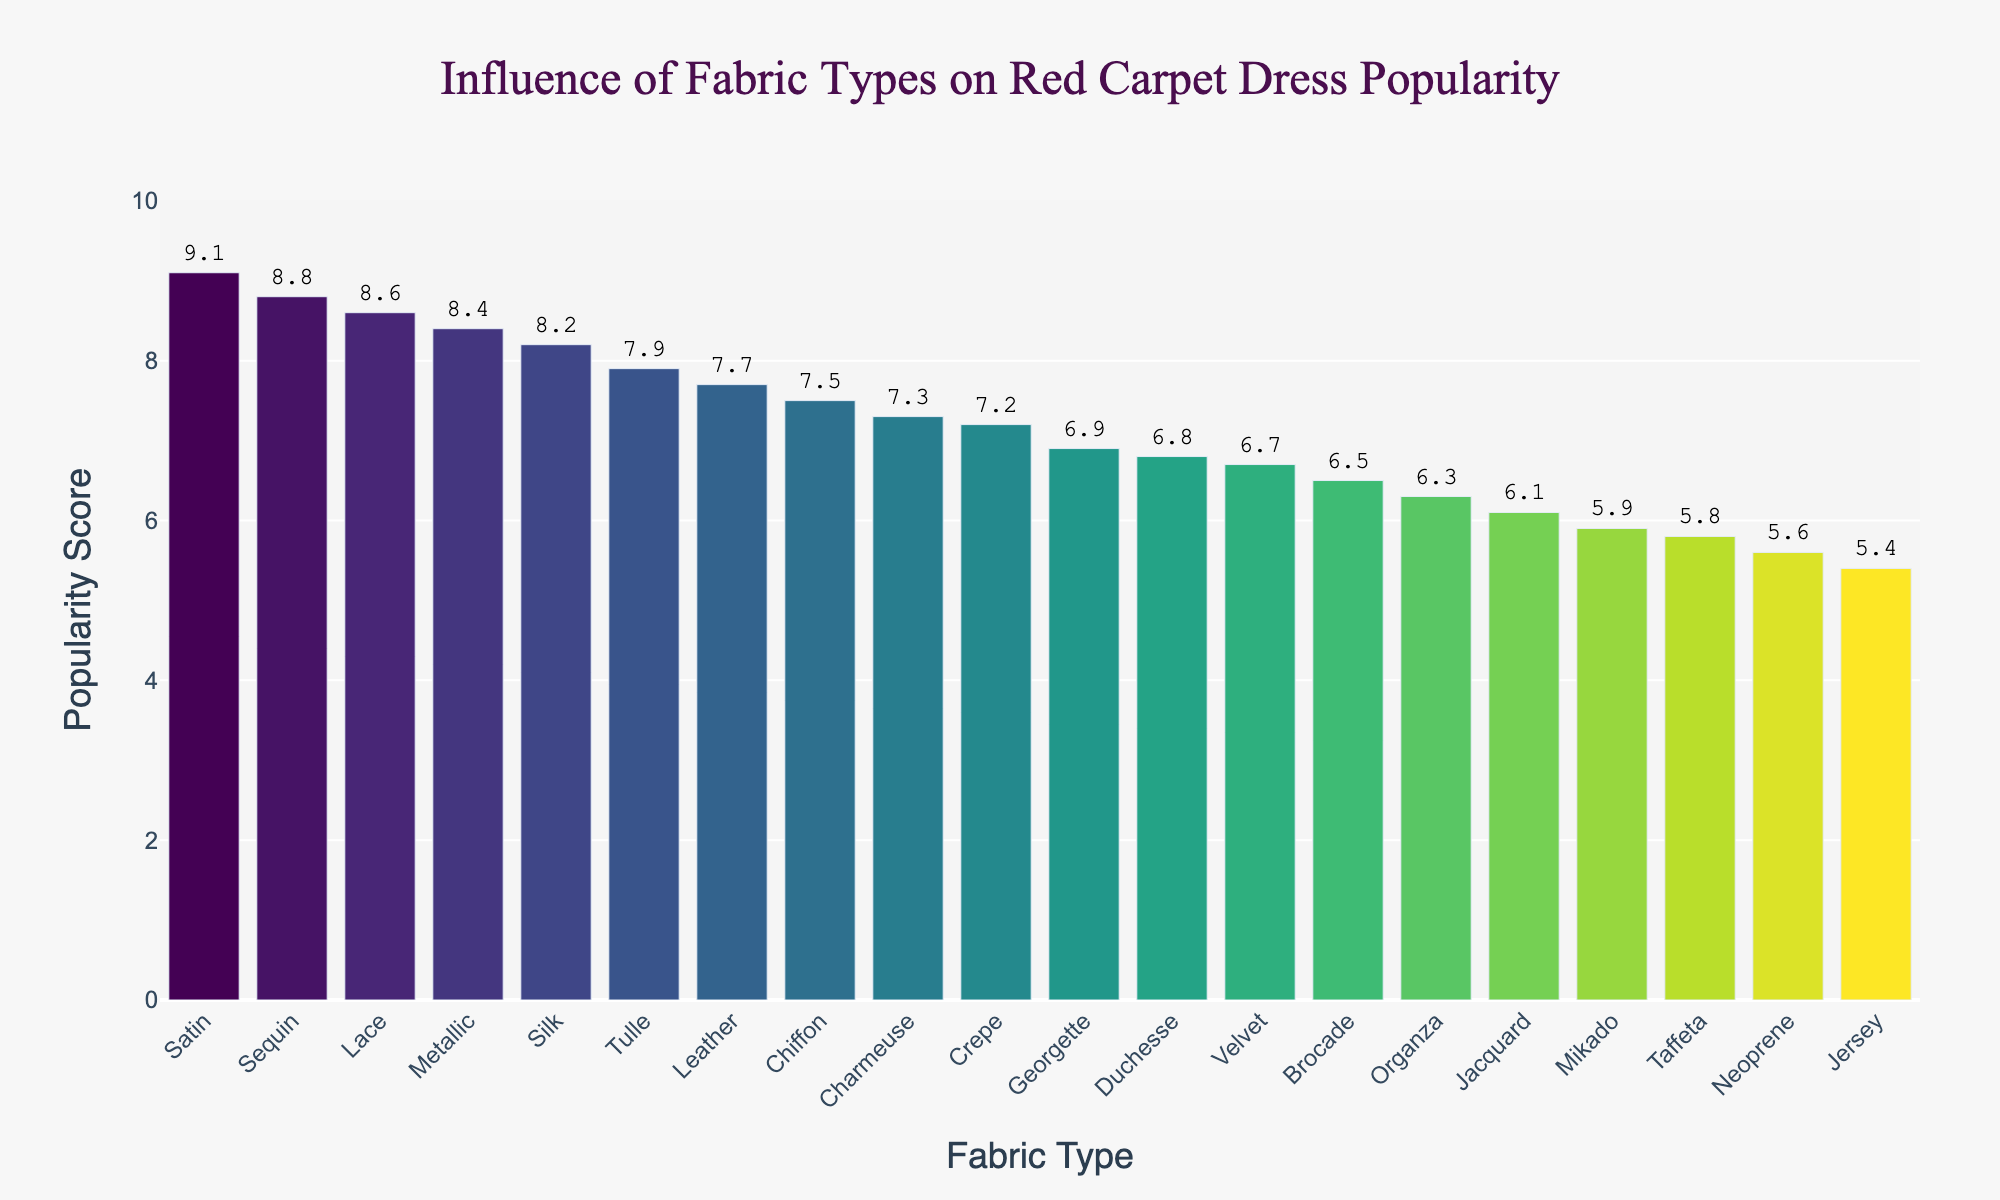Which fabric type has the highest popularity score? The figure shows different fabric types with their corresponding popularity scores. The bar with the highest value is Satin with a score of 9.1
Answer: Satin What's the title of the plot? The title is displayed at the top of the plot and reads "Influence of Fabric Types on Red Carpet Dress Popularity"
Answer: Influence of Fabric Types on Red Carpet Dress Popularity How many fabric types have a popularity score above 8.0? By visually inspecting the bars that go above the 8.0 mark on the y-axis, we note the fabric types: Silk, Satin, Lace, Sequin, and Metallic, making a total of 5
Answer: 5 What's the average popularity score of the fabrics shown? Sum the popularity scores of all fabrics and divide by the number of fabric types (19). The sum is 7.04 and hence the average popularity score is 7.04.
Answer: 7.04 Which fabric type has the lowest popularity score, and what's the score? The figure shows Jersey with the lowest bar, indicating a popularity score of 5.4
Answer: Jersey, 5.4 What's the color scheme used in the plot? The color scheme is indicated by a gradient that goes through various hues in the Viridis color scale
Answer: Viridis Which two fabric types have almost equal popularity scores and what are their scores? By looking at the plot, Velvet and Duchesse have similar popularity scores, both slightly under 7.0
Answer: Velvet and Duchesse, 6.7 and 6.8 What's the difference in popularity score between Silk and Organza? Silk has a popularity score of 8.2 and Organza has a score of 6.3. The difference is 8.2 - 6.3 = 1.9
Answer: 1.9 If a fabric type needs at least a score of 7.0 to be considered trendy, how many trendy fabrics are there? By checking the bars that reach or exceed the 7.0 mark, we identify: Silk, Chiffon, Satin, Tulle, Lace, Sequin, Crepe, Leather, Metallic, Charmeuse, totaling 10 fabrics
Answer: 10 Is there a visible trend in popularity scores correlated to fabric types? Visually inspecting the plot, specific types like light and shiny fabrics (e.g., Satin, Lace, Sequin) have higher scores, whereas more structured fabrics (e.g., Brocade, Neoprene, Jacquard) have lower scores.
Answer: Yes, lighter and shinier fabrics are more popular 